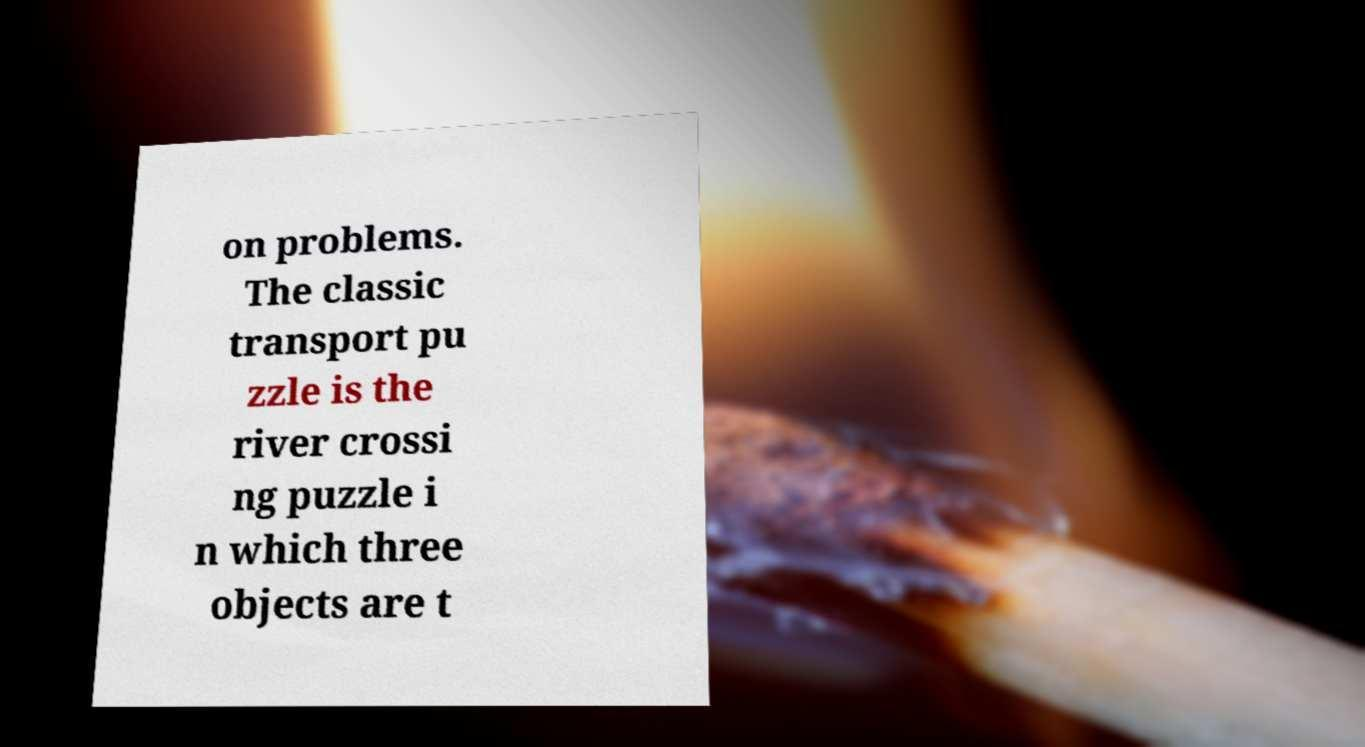Can you accurately transcribe the text from the provided image for me? on problems. The classic transport pu zzle is the river crossi ng puzzle i n which three objects are t 